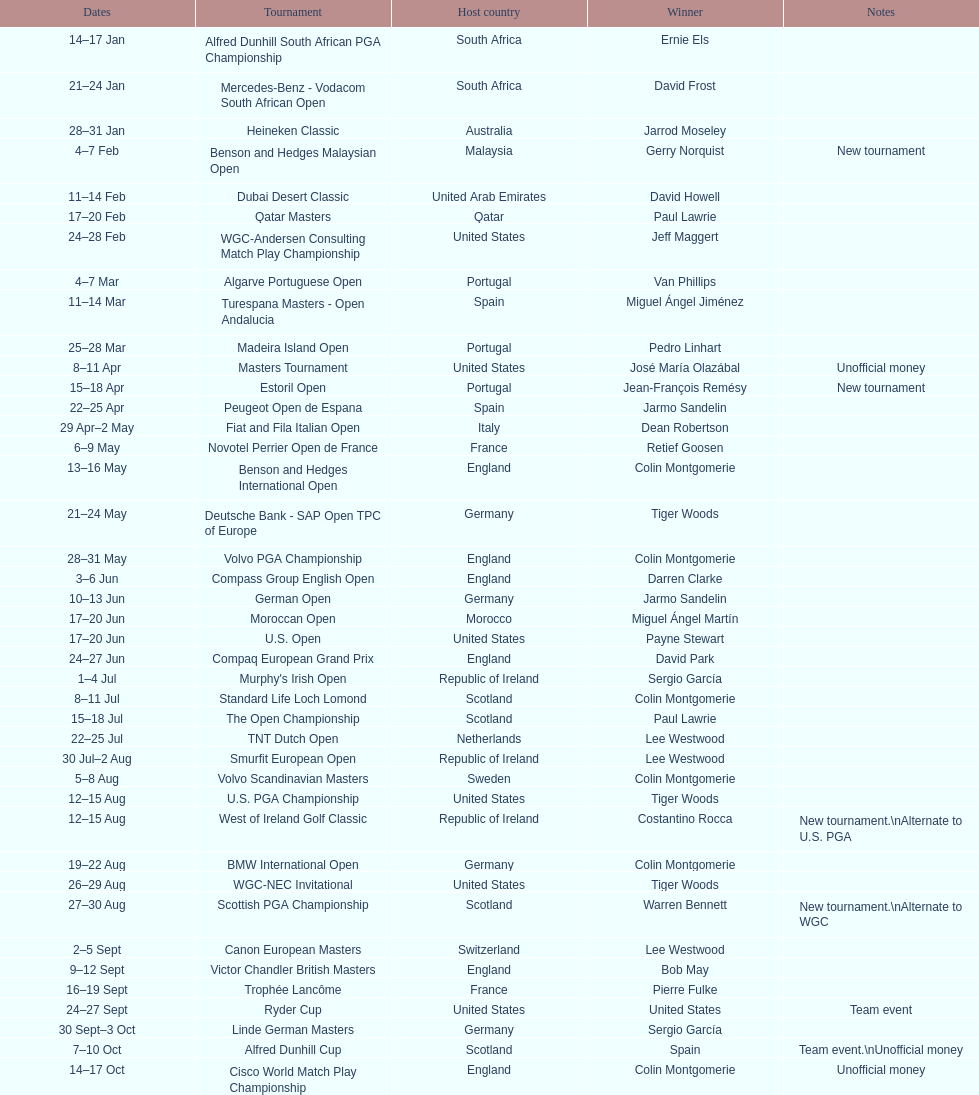How many successive times was south africa the host nation? 2. 